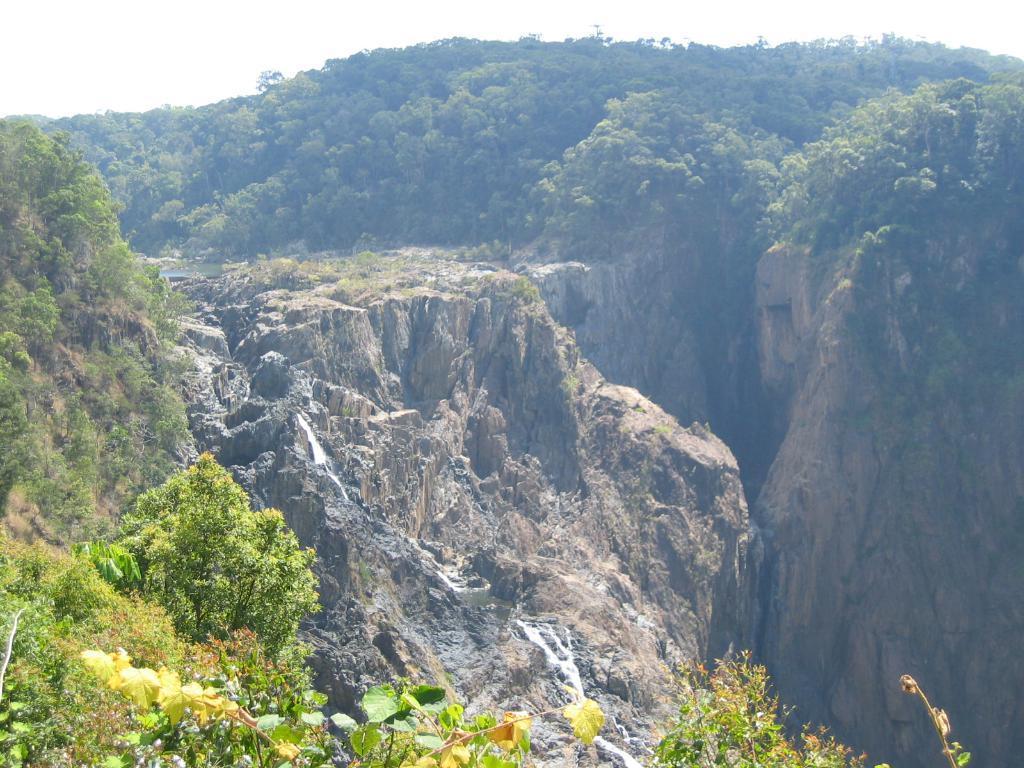In one or two sentences, can you explain what this image depicts? There are trees on a mountain. In the background, there is a water fall from the mountain, there are other mountains and there are clouds in the sky. 